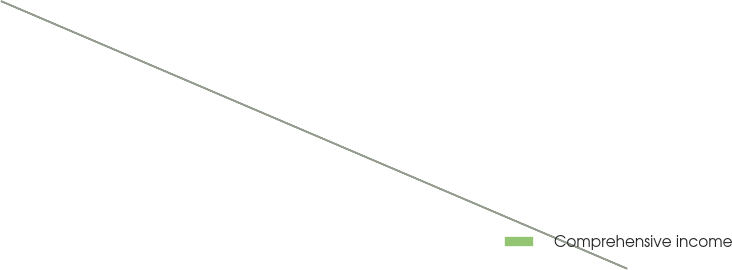Convert chart. <chart><loc_0><loc_0><loc_500><loc_500><pie_chart><fcel>Comprehensive income<nl><fcel>100.0%<nl></chart> 